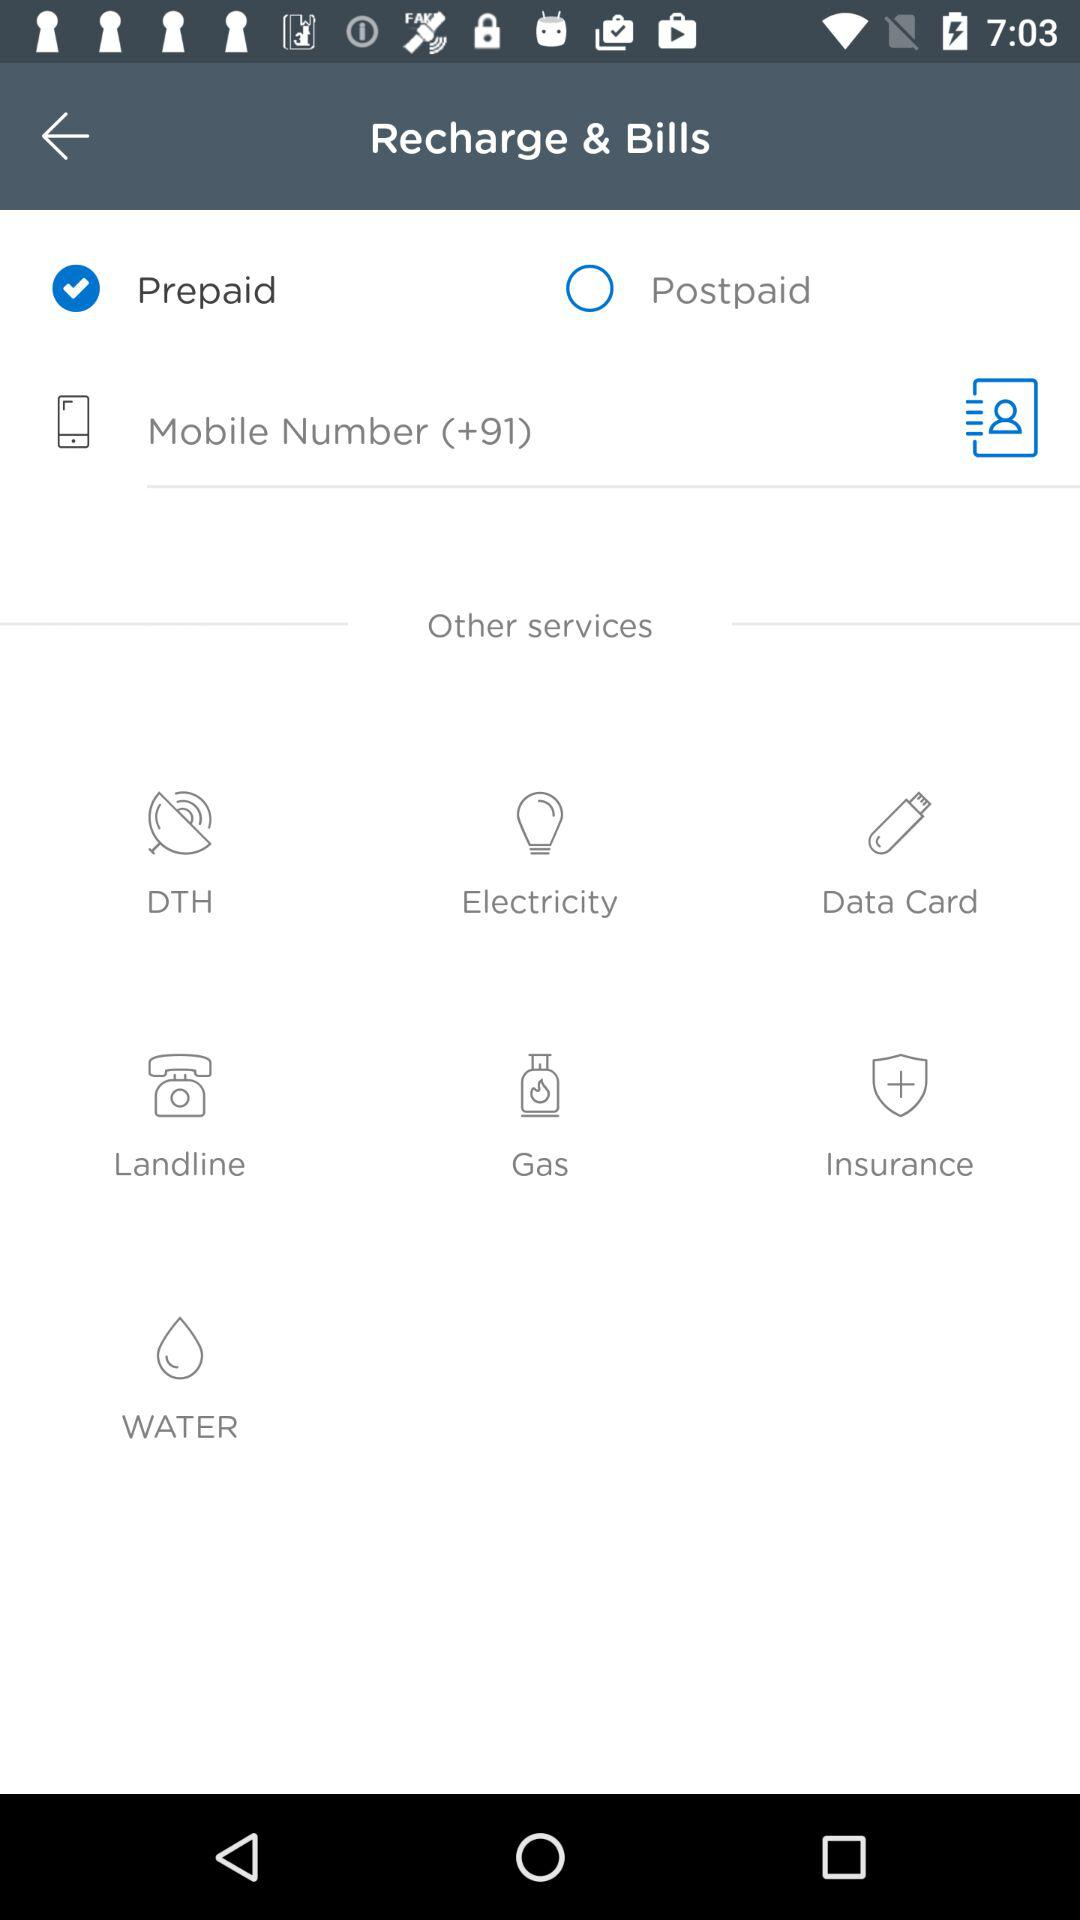Which option was selected? The selected option is "Prepaid". 